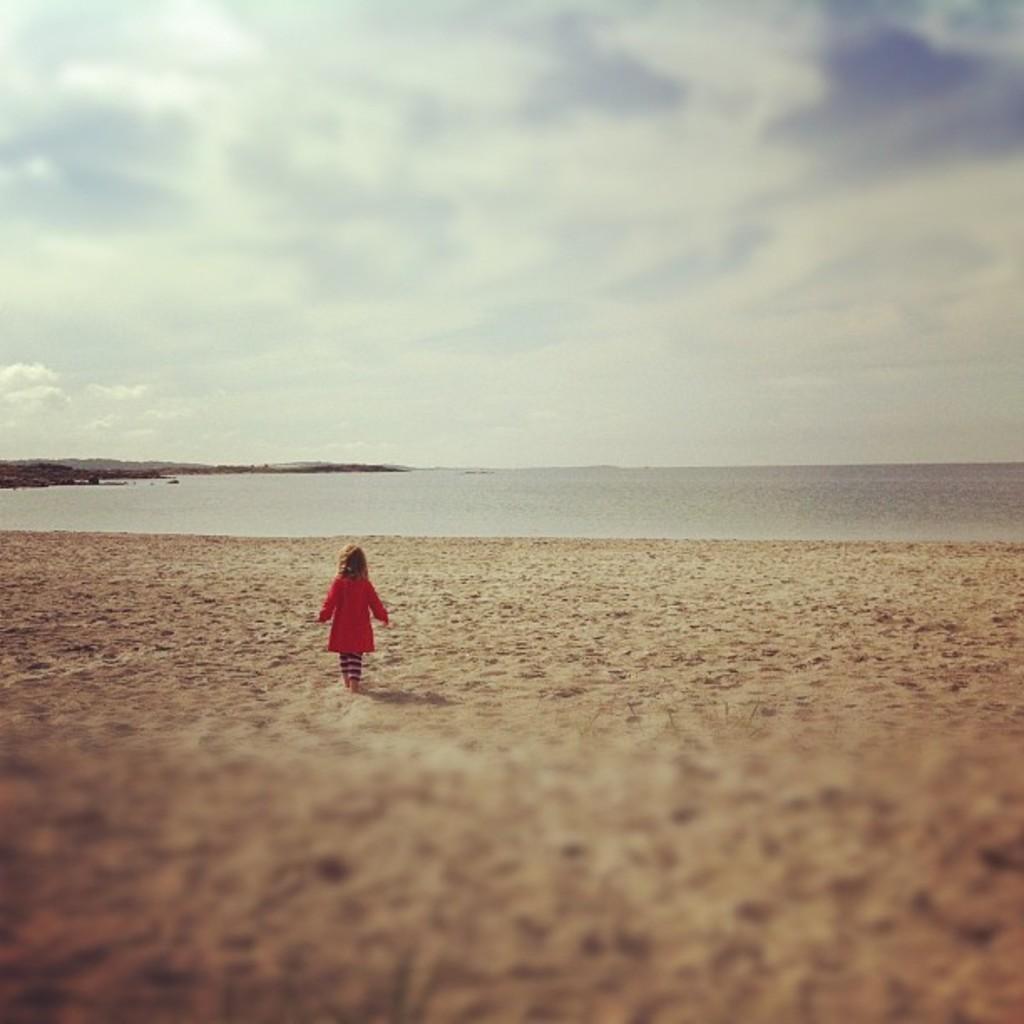Please provide a concise description of this image. In this picture we can see a kid is walking, at the bottom there is sand, in the background we can see water, there is the sky and clouds at the top of the picture. 